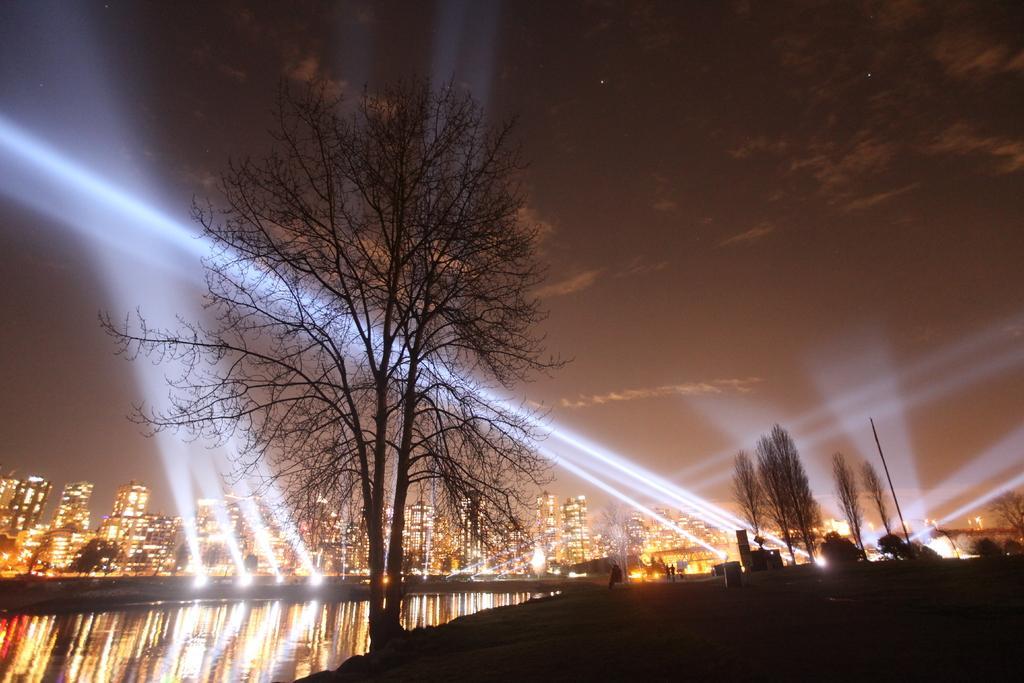Could you give a brief overview of what you see in this image? this is a picture of a city taken in the dark,the picture consists of buildings, lights and a canal and a couple of trees and a sky with stars and clouds. 